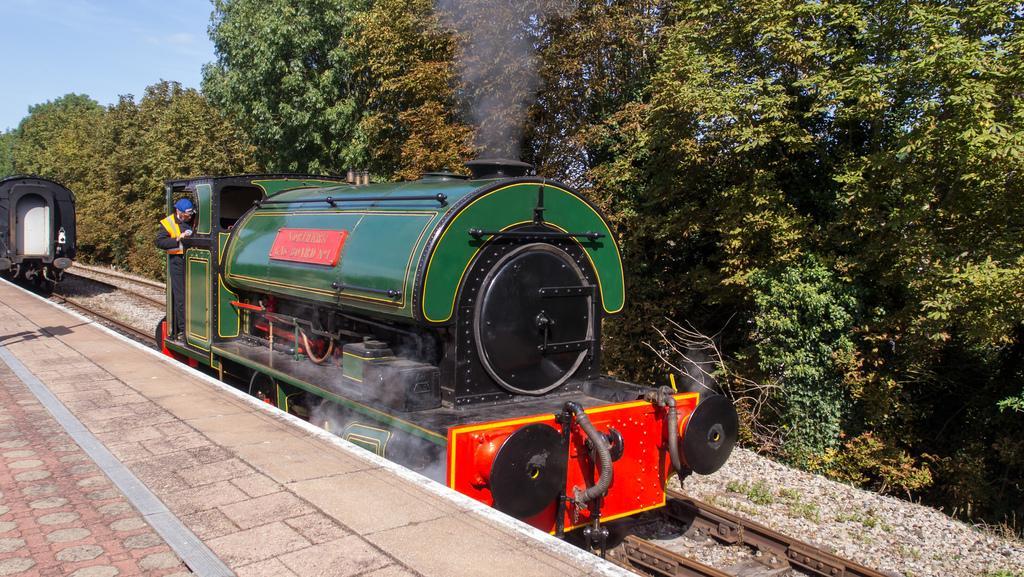How would you summarize this image in a sentence or two? In the center of the image we can see a person standing in a locomotive placed on the track. In the foreground we can see a pathway. In the background, we can see a wagon, group of trees and the sky. 